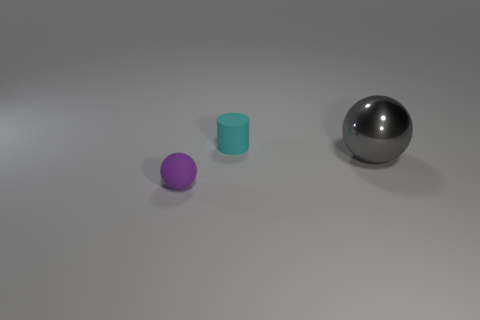Add 2 gray metal spheres. How many objects exist? 5 Subtract all cylinders. How many objects are left? 2 Add 2 big brown metallic cylinders. How many big brown metallic cylinders exist? 2 Subtract 0 green cylinders. How many objects are left? 3 Subtract all small cyan blocks. Subtract all tiny cyan cylinders. How many objects are left? 2 Add 3 small purple rubber objects. How many small purple rubber objects are left? 4 